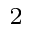Convert formula to latex. <formula><loc_0><loc_0><loc_500><loc_500>^ { 2 }</formula> 